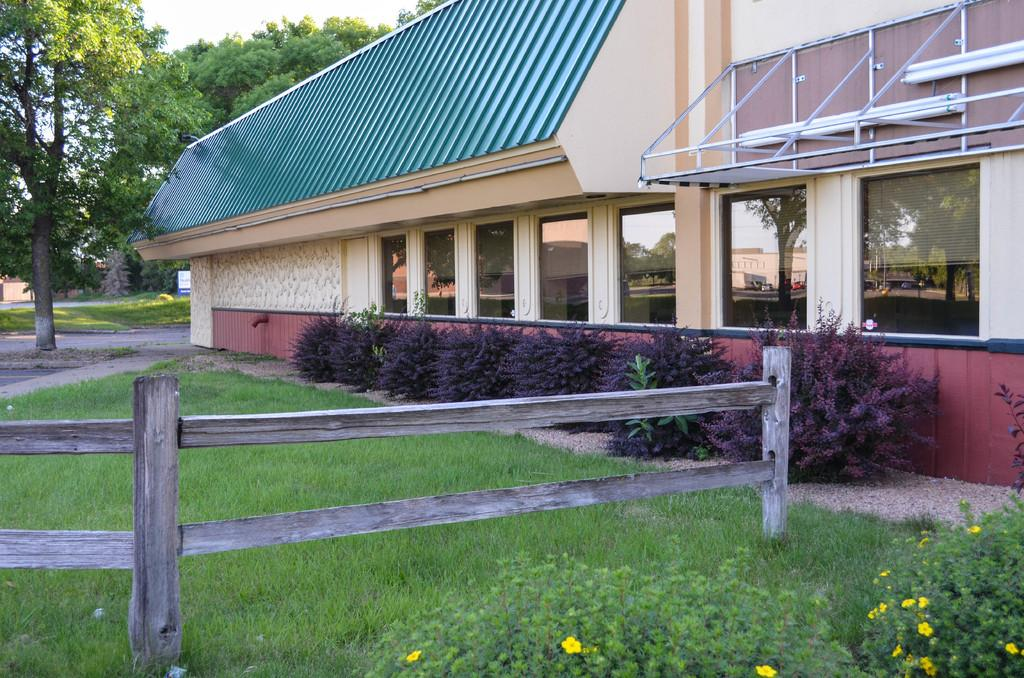What type of plants can be seen in the image? There are yellow flower plants in the image. What material is the fence made of? The fence in the image is made of wood. What type of vegetation is present in the image? There is grass and plants in the image. What is the structure on the left side of the image? There is a building with glass windows on the left side of the image. What can be seen in the background of the image? There are trees at the back of the image. What type of pets can be seen playing in the grass in the image? There are no pets visible in the image; it only features plants, a wooden fence, grass, and a building. What does the image smell like? The image does not have a smell, as it is a visual representation. 